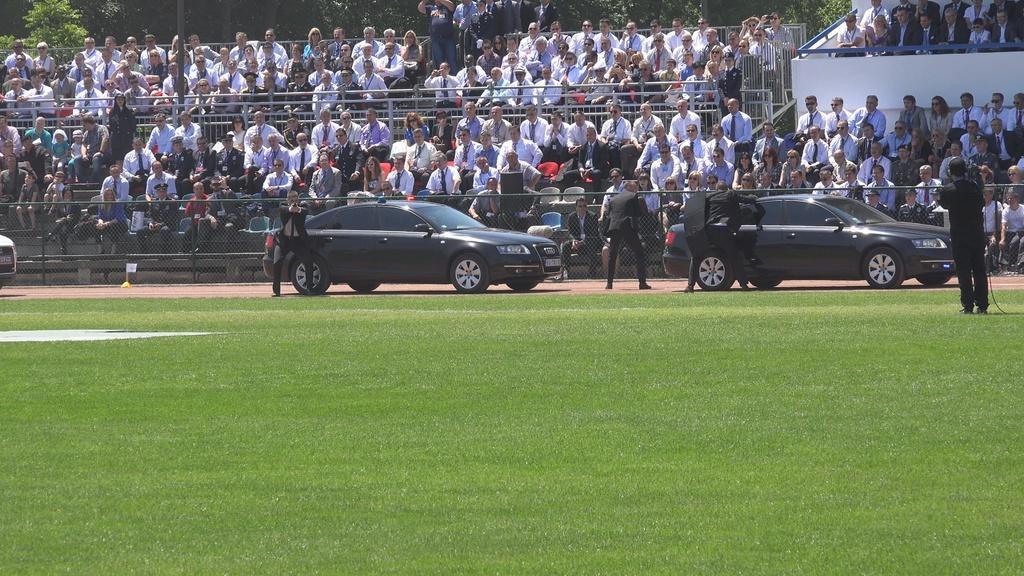Please provide a concise description of this image. In this image we can see some cars on the ground. We can also see grass and some people standing beside the cars. On the backside we can see a group of people sitting beside the fence. We can also see some poles and a group of trees. 